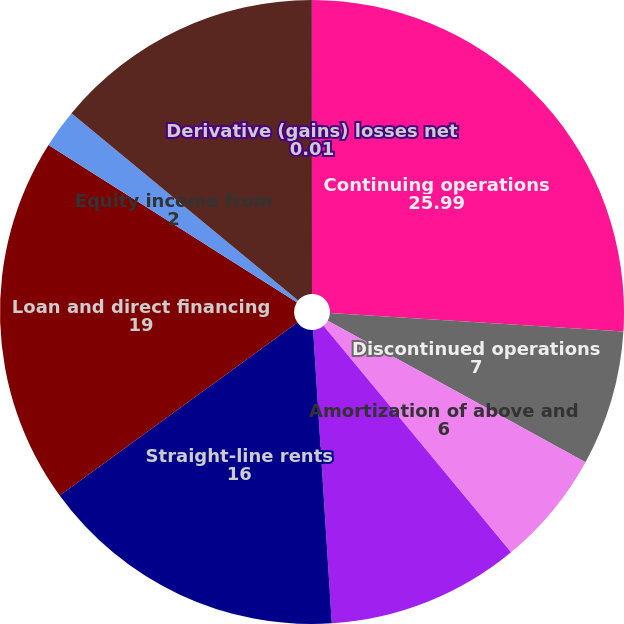<chart> <loc_0><loc_0><loc_500><loc_500><pie_chart><fcel>Continuing operations<fcel>Discontinued operations<fcel>Amortization of above and<fcel>Amortization of deferred<fcel>Straight-line rents<fcel>Loan and direct financing<fcel>Equity income from<fcel>Gain on sales of real estate<fcel>Derivative (gains) losses net<nl><fcel>25.99%<fcel>7.0%<fcel>6.0%<fcel>10.0%<fcel>16.0%<fcel>19.0%<fcel>2.0%<fcel>14.0%<fcel>0.01%<nl></chart> 